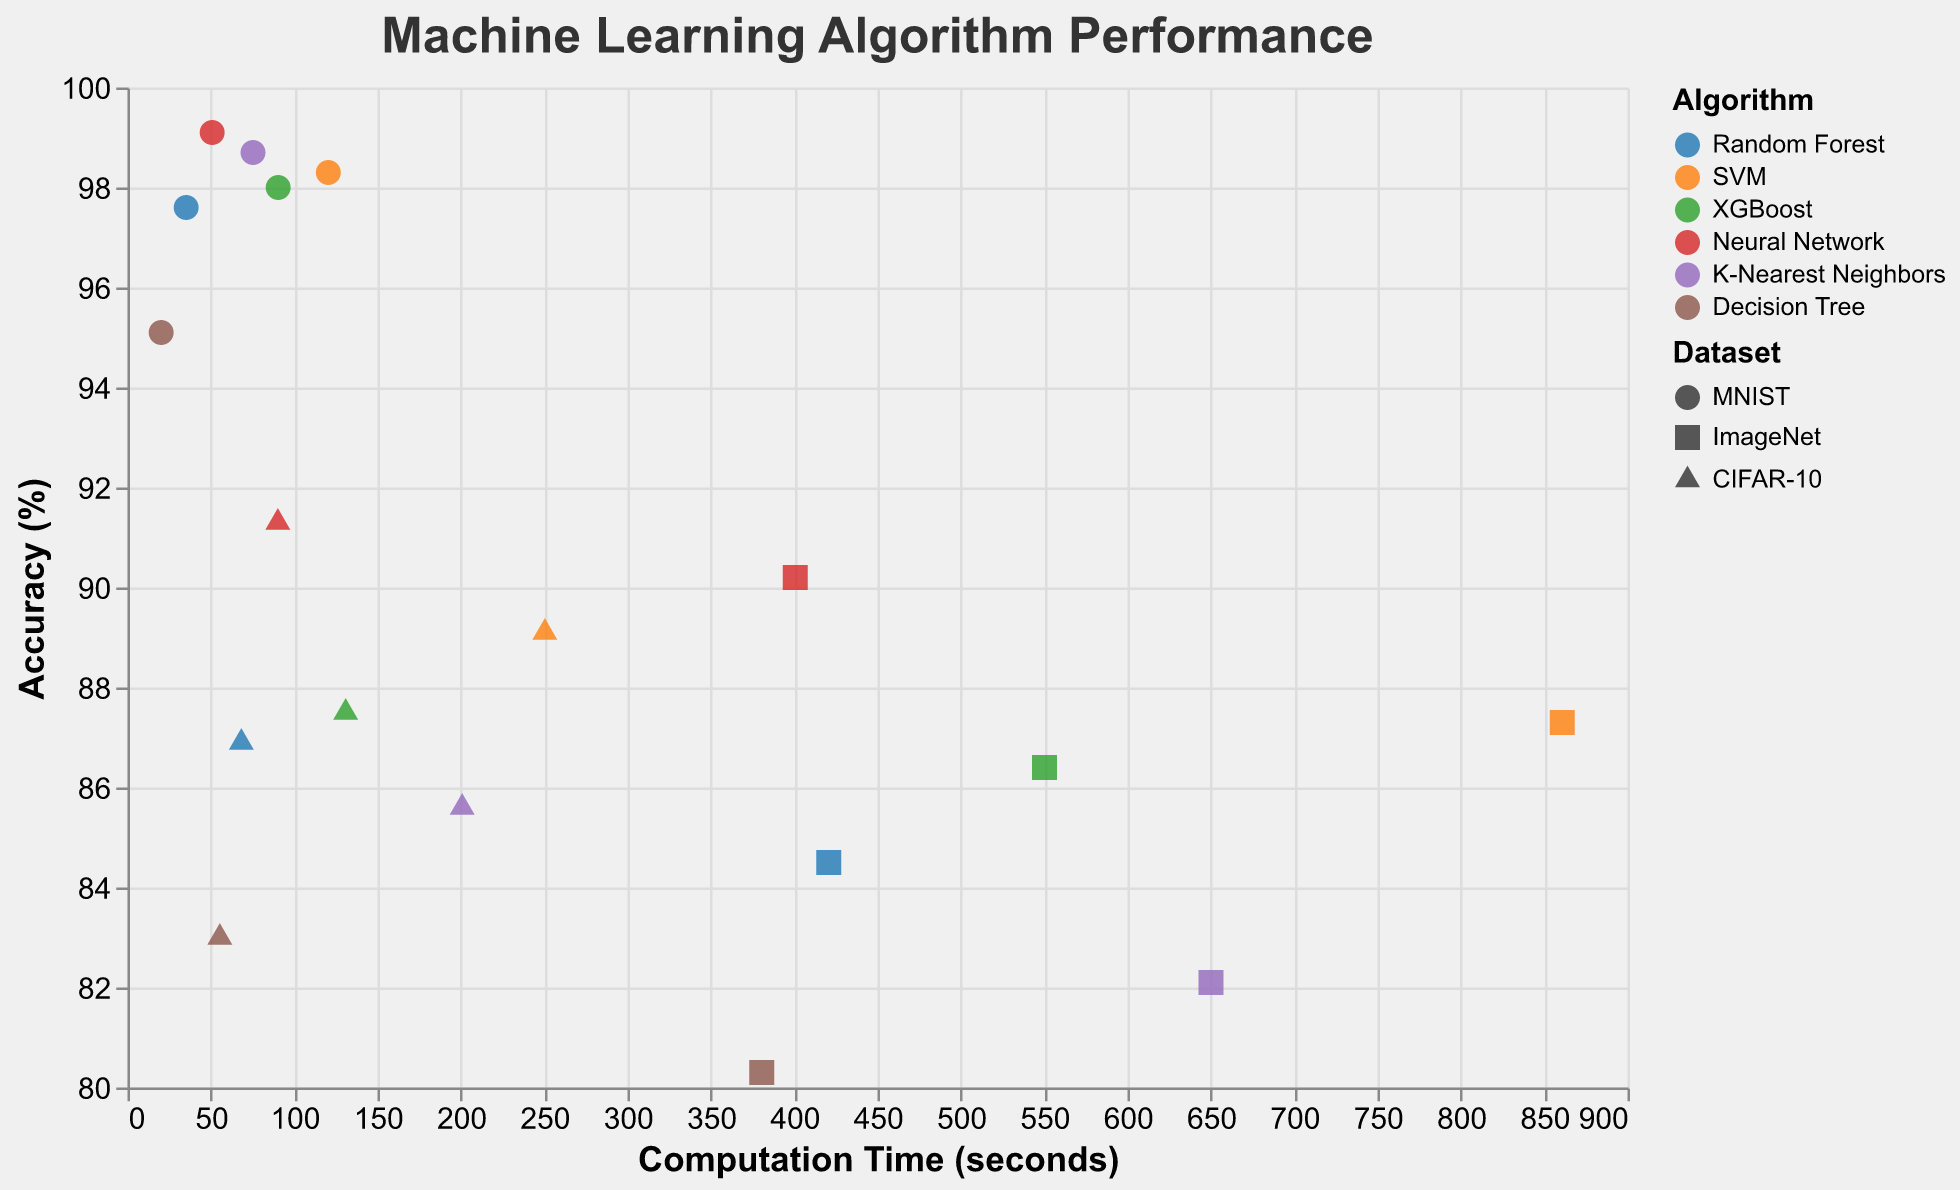What is the title of the figure? The title can be found at the top of the figure. It states "Machine Learning Algorithm Performance".
Answer: Machine Learning Algorithm Performance What color is used to represent the Random Forest algorithm? The color can be found in the legend, which maps algorithms to colors. The legend shows Random Forest is represented by a shade of blue.
Answer: Blue Which dataset-shape represents ImageNet? The shape can be found in the legend that maps datasets to shapes. The legend shows that ImageNet is represented by a square.
Answer: Square How does the accuracy of Decision Tree on the MNIST dataset compare to Random Forest on the same dataset? Find the points corresponding to Decision Tree on MNIST and Random Forest on MNIST. Compare their Accuracy (%) values. Decision Tree has about 95.1% accuracy, while Random Forest has about 97.6% accuracy.
Answer: Random Forest is higher Which algorithm has the highest accuracy on the CIFAR-10 dataset? Identify the points representing each algorithm on the CIFAR-10 dataset and compare their Accuracy (%) values. The Neural Network shows the highest accuracy, about 91.3%.
Answer: Neural Network What is the average accuracy of K-Nearest Neighbors across all datasets? Find the points corresponding to K-Nearest Neighbors and note their accuracy values: 98.7%, 82.1%, and 85.6%. Average these values: (98.7 + 82.1 + 85.6) / 3 = 88.8%.
Answer: 88.8% Which algorithm has the longest computation time on any dataset? Look for the point with the maximum Computation Time (seconds) across all algorithms and datasets. SVM on ImageNet shows the highest computation time, about 860.9 seconds.
Answer: SVM How does the computation time of Neural Network on ImageNet compare to XGBoost on the same dataset? Find the points corresponding to Neural Network on ImageNet and XGBoost on ImageNet. Compare their Computation Time (seconds) values. Neural Network has about 400.6 seconds, while XGBoost has about 550.2 seconds.
Answer: Neural Network is shorter Which algorithm has the lowest accuracy on the ImageNet dataset? Among the points representing ImageNet dataset, observe the algorithms and their Accuracy (%) values. Decision Tree has the lowest accuracy, about 80.3%.
Answer: Decision Tree 